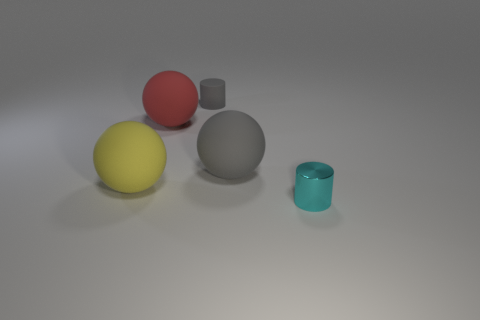What number of gray spheres have the same material as the gray cylinder?
Provide a short and direct response. 1. There is a gray rubber ball; is it the same size as the cylinder left of the small cyan thing?
Give a very brief answer. No. There is a thing that is both on the left side of the tiny cyan object and on the right side of the tiny matte cylinder; what is its color?
Ensure brevity in your answer.  Gray. There is a tiny cylinder that is to the left of the shiny object; is there a tiny matte object that is in front of it?
Ensure brevity in your answer.  No. Are there an equal number of metallic cylinders behind the small rubber object and cyan cubes?
Give a very brief answer. Yes. There is a large sphere in front of the big object on the right side of the tiny rubber cylinder; what number of big rubber things are in front of it?
Keep it short and to the point. 0. Are there any other matte objects that have the same size as the red rubber thing?
Your answer should be very brief. Yes. Are there fewer big red matte objects behind the tiny matte cylinder than cyan metal things?
Ensure brevity in your answer.  Yes. There is a cylinder that is right of the cylinder that is left of the cylinder on the right side of the small rubber cylinder; what is it made of?
Offer a terse response. Metal. Are there more small metal cylinders that are on the left side of the tiny metal cylinder than gray matte cylinders that are right of the yellow object?
Your response must be concise. No. 